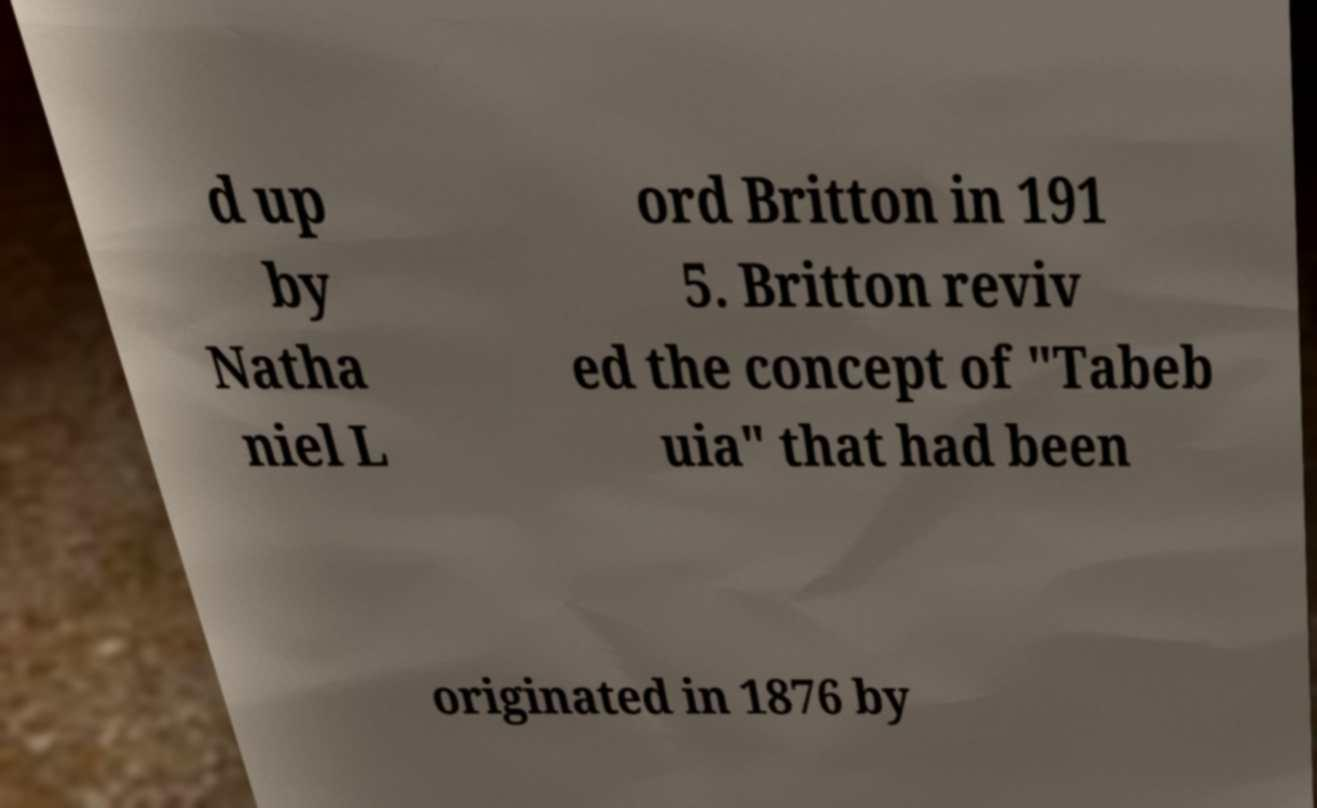Please read and relay the text visible in this image. What does it say? d up by Natha niel L ord Britton in 191 5. Britton reviv ed the concept of "Tabeb uia" that had been originated in 1876 by 